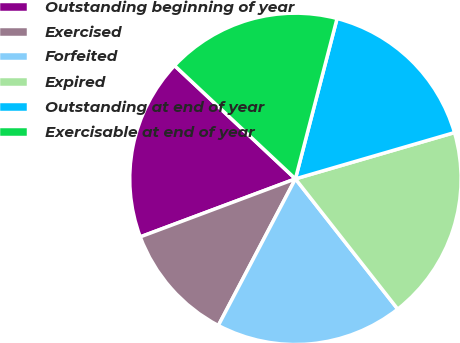Convert chart to OTSL. <chart><loc_0><loc_0><loc_500><loc_500><pie_chart><fcel>Outstanding beginning of year<fcel>Exercised<fcel>Forfeited<fcel>Expired<fcel>Outstanding at end of year<fcel>Exercisable at end of year<nl><fcel>17.68%<fcel>11.6%<fcel>18.3%<fcel>18.91%<fcel>16.45%<fcel>17.06%<nl></chart> 